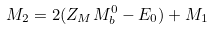Convert formula to latex. <formula><loc_0><loc_0><loc_500><loc_500>M _ { 2 } = 2 ( Z _ { M } M ^ { 0 } _ { b } - E _ { 0 } ) + M _ { 1 }</formula> 